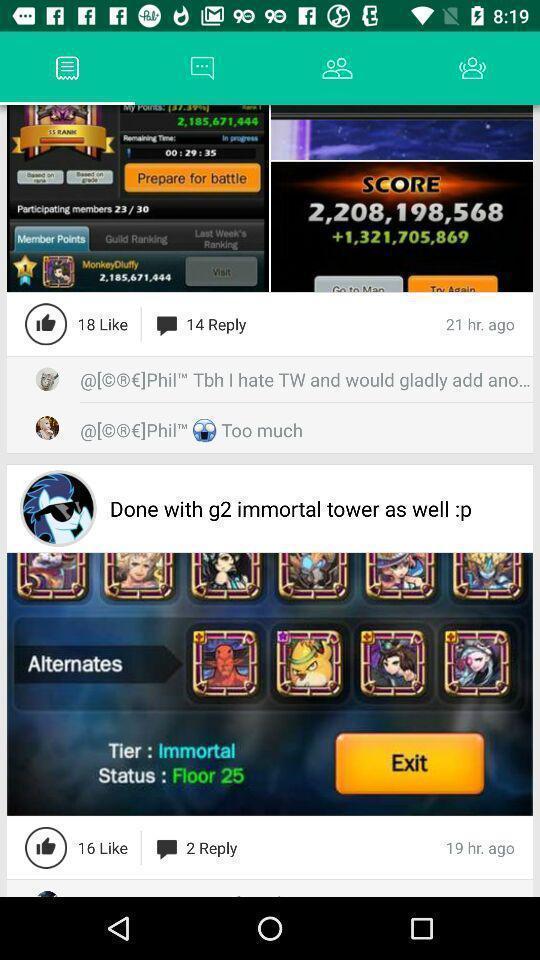What is the overall content of this screenshot? Video with likes and replies. 